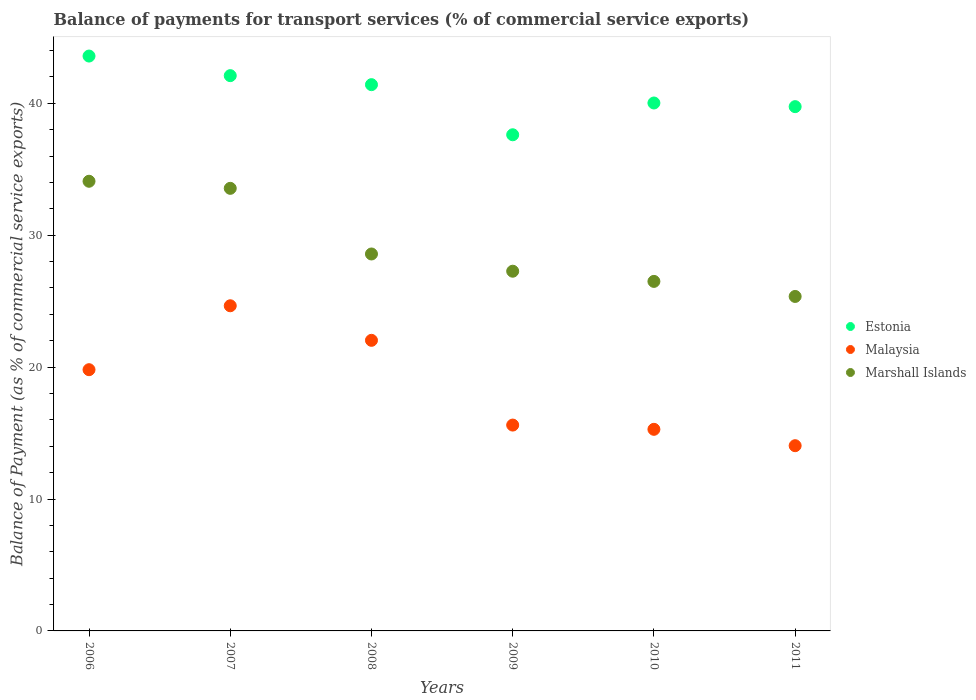How many different coloured dotlines are there?
Your response must be concise. 3. Is the number of dotlines equal to the number of legend labels?
Your answer should be very brief. Yes. What is the balance of payments for transport services in Marshall Islands in 2008?
Your response must be concise. 28.57. Across all years, what is the maximum balance of payments for transport services in Estonia?
Your response must be concise. 43.58. Across all years, what is the minimum balance of payments for transport services in Malaysia?
Your response must be concise. 14.04. In which year was the balance of payments for transport services in Malaysia maximum?
Keep it short and to the point. 2007. In which year was the balance of payments for transport services in Estonia minimum?
Keep it short and to the point. 2009. What is the total balance of payments for transport services in Marshall Islands in the graph?
Offer a very short reply. 175.33. What is the difference between the balance of payments for transport services in Malaysia in 2008 and that in 2010?
Provide a short and direct response. 6.75. What is the difference between the balance of payments for transport services in Malaysia in 2011 and the balance of payments for transport services in Estonia in 2007?
Give a very brief answer. -28.05. What is the average balance of payments for transport services in Marshall Islands per year?
Make the answer very short. 29.22. In the year 2011, what is the difference between the balance of payments for transport services in Marshall Islands and balance of payments for transport services in Malaysia?
Provide a short and direct response. 11.31. What is the ratio of the balance of payments for transport services in Marshall Islands in 2009 to that in 2010?
Provide a short and direct response. 1.03. What is the difference between the highest and the second highest balance of payments for transport services in Estonia?
Provide a short and direct response. 1.49. What is the difference between the highest and the lowest balance of payments for transport services in Malaysia?
Provide a succinct answer. 10.61. In how many years, is the balance of payments for transport services in Malaysia greater than the average balance of payments for transport services in Malaysia taken over all years?
Provide a succinct answer. 3. Does the balance of payments for transport services in Estonia monotonically increase over the years?
Your response must be concise. No. Is the balance of payments for transport services in Estonia strictly greater than the balance of payments for transport services in Marshall Islands over the years?
Your answer should be very brief. Yes. Is the balance of payments for transport services in Malaysia strictly less than the balance of payments for transport services in Marshall Islands over the years?
Make the answer very short. Yes. How many dotlines are there?
Keep it short and to the point. 3. Are the values on the major ticks of Y-axis written in scientific E-notation?
Make the answer very short. No. Does the graph contain grids?
Your answer should be very brief. No. Where does the legend appear in the graph?
Give a very brief answer. Center right. What is the title of the graph?
Your response must be concise. Balance of payments for transport services (% of commercial service exports). What is the label or title of the X-axis?
Ensure brevity in your answer.  Years. What is the label or title of the Y-axis?
Provide a succinct answer. Balance of Payment (as % of commercial service exports). What is the Balance of Payment (as % of commercial service exports) in Estonia in 2006?
Your response must be concise. 43.58. What is the Balance of Payment (as % of commercial service exports) in Malaysia in 2006?
Ensure brevity in your answer.  19.8. What is the Balance of Payment (as % of commercial service exports) of Marshall Islands in 2006?
Your answer should be compact. 34.09. What is the Balance of Payment (as % of commercial service exports) in Estonia in 2007?
Ensure brevity in your answer.  42.09. What is the Balance of Payment (as % of commercial service exports) in Malaysia in 2007?
Your response must be concise. 24.65. What is the Balance of Payment (as % of commercial service exports) in Marshall Islands in 2007?
Keep it short and to the point. 33.55. What is the Balance of Payment (as % of commercial service exports) in Estonia in 2008?
Your answer should be compact. 41.41. What is the Balance of Payment (as % of commercial service exports) in Malaysia in 2008?
Your response must be concise. 22.03. What is the Balance of Payment (as % of commercial service exports) in Marshall Islands in 2008?
Offer a very short reply. 28.57. What is the Balance of Payment (as % of commercial service exports) in Estonia in 2009?
Your answer should be very brief. 37.61. What is the Balance of Payment (as % of commercial service exports) of Malaysia in 2009?
Your answer should be compact. 15.6. What is the Balance of Payment (as % of commercial service exports) of Marshall Islands in 2009?
Provide a succinct answer. 27.27. What is the Balance of Payment (as % of commercial service exports) in Estonia in 2010?
Offer a terse response. 40.02. What is the Balance of Payment (as % of commercial service exports) in Malaysia in 2010?
Offer a very short reply. 15.28. What is the Balance of Payment (as % of commercial service exports) of Marshall Islands in 2010?
Provide a succinct answer. 26.5. What is the Balance of Payment (as % of commercial service exports) of Estonia in 2011?
Ensure brevity in your answer.  39.74. What is the Balance of Payment (as % of commercial service exports) of Malaysia in 2011?
Offer a terse response. 14.04. What is the Balance of Payment (as % of commercial service exports) of Marshall Islands in 2011?
Keep it short and to the point. 25.35. Across all years, what is the maximum Balance of Payment (as % of commercial service exports) of Estonia?
Offer a terse response. 43.58. Across all years, what is the maximum Balance of Payment (as % of commercial service exports) of Malaysia?
Your answer should be very brief. 24.65. Across all years, what is the maximum Balance of Payment (as % of commercial service exports) of Marshall Islands?
Provide a succinct answer. 34.09. Across all years, what is the minimum Balance of Payment (as % of commercial service exports) of Estonia?
Your response must be concise. 37.61. Across all years, what is the minimum Balance of Payment (as % of commercial service exports) in Malaysia?
Give a very brief answer. 14.04. Across all years, what is the minimum Balance of Payment (as % of commercial service exports) in Marshall Islands?
Your response must be concise. 25.35. What is the total Balance of Payment (as % of commercial service exports) of Estonia in the graph?
Your answer should be compact. 244.45. What is the total Balance of Payment (as % of commercial service exports) in Malaysia in the graph?
Keep it short and to the point. 111.41. What is the total Balance of Payment (as % of commercial service exports) in Marshall Islands in the graph?
Your response must be concise. 175.33. What is the difference between the Balance of Payment (as % of commercial service exports) of Estonia in 2006 and that in 2007?
Ensure brevity in your answer.  1.49. What is the difference between the Balance of Payment (as % of commercial service exports) of Malaysia in 2006 and that in 2007?
Offer a terse response. -4.85. What is the difference between the Balance of Payment (as % of commercial service exports) of Marshall Islands in 2006 and that in 2007?
Give a very brief answer. 0.54. What is the difference between the Balance of Payment (as % of commercial service exports) in Estonia in 2006 and that in 2008?
Ensure brevity in your answer.  2.17. What is the difference between the Balance of Payment (as % of commercial service exports) in Malaysia in 2006 and that in 2008?
Provide a succinct answer. -2.23. What is the difference between the Balance of Payment (as % of commercial service exports) in Marshall Islands in 2006 and that in 2008?
Ensure brevity in your answer.  5.51. What is the difference between the Balance of Payment (as % of commercial service exports) of Estonia in 2006 and that in 2009?
Provide a short and direct response. 5.97. What is the difference between the Balance of Payment (as % of commercial service exports) of Malaysia in 2006 and that in 2009?
Provide a short and direct response. 4.2. What is the difference between the Balance of Payment (as % of commercial service exports) of Marshall Islands in 2006 and that in 2009?
Offer a terse response. 6.82. What is the difference between the Balance of Payment (as % of commercial service exports) in Estonia in 2006 and that in 2010?
Give a very brief answer. 3.56. What is the difference between the Balance of Payment (as % of commercial service exports) of Malaysia in 2006 and that in 2010?
Make the answer very short. 4.52. What is the difference between the Balance of Payment (as % of commercial service exports) in Marshall Islands in 2006 and that in 2010?
Offer a terse response. 7.59. What is the difference between the Balance of Payment (as % of commercial service exports) of Estonia in 2006 and that in 2011?
Your answer should be compact. 3.83. What is the difference between the Balance of Payment (as % of commercial service exports) in Malaysia in 2006 and that in 2011?
Offer a very short reply. 5.76. What is the difference between the Balance of Payment (as % of commercial service exports) of Marshall Islands in 2006 and that in 2011?
Offer a very short reply. 8.73. What is the difference between the Balance of Payment (as % of commercial service exports) in Estonia in 2007 and that in 2008?
Give a very brief answer. 0.68. What is the difference between the Balance of Payment (as % of commercial service exports) of Malaysia in 2007 and that in 2008?
Provide a succinct answer. 2.62. What is the difference between the Balance of Payment (as % of commercial service exports) of Marshall Islands in 2007 and that in 2008?
Give a very brief answer. 4.98. What is the difference between the Balance of Payment (as % of commercial service exports) in Estonia in 2007 and that in 2009?
Offer a very short reply. 4.48. What is the difference between the Balance of Payment (as % of commercial service exports) in Malaysia in 2007 and that in 2009?
Ensure brevity in your answer.  9.04. What is the difference between the Balance of Payment (as % of commercial service exports) in Marshall Islands in 2007 and that in 2009?
Your response must be concise. 6.28. What is the difference between the Balance of Payment (as % of commercial service exports) of Estonia in 2007 and that in 2010?
Your answer should be compact. 2.07. What is the difference between the Balance of Payment (as % of commercial service exports) of Malaysia in 2007 and that in 2010?
Keep it short and to the point. 9.37. What is the difference between the Balance of Payment (as % of commercial service exports) of Marshall Islands in 2007 and that in 2010?
Offer a very short reply. 7.05. What is the difference between the Balance of Payment (as % of commercial service exports) in Estonia in 2007 and that in 2011?
Keep it short and to the point. 2.35. What is the difference between the Balance of Payment (as % of commercial service exports) of Malaysia in 2007 and that in 2011?
Offer a terse response. 10.61. What is the difference between the Balance of Payment (as % of commercial service exports) in Marshall Islands in 2007 and that in 2011?
Ensure brevity in your answer.  8.2. What is the difference between the Balance of Payment (as % of commercial service exports) of Estonia in 2008 and that in 2009?
Give a very brief answer. 3.8. What is the difference between the Balance of Payment (as % of commercial service exports) in Malaysia in 2008 and that in 2009?
Your answer should be compact. 6.42. What is the difference between the Balance of Payment (as % of commercial service exports) in Marshall Islands in 2008 and that in 2009?
Provide a short and direct response. 1.31. What is the difference between the Balance of Payment (as % of commercial service exports) in Estonia in 2008 and that in 2010?
Give a very brief answer. 1.39. What is the difference between the Balance of Payment (as % of commercial service exports) in Malaysia in 2008 and that in 2010?
Give a very brief answer. 6.75. What is the difference between the Balance of Payment (as % of commercial service exports) of Marshall Islands in 2008 and that in 2010?
Provide a short and direct response. 2.08. What is the difference between the Balance of Payment (as % of commercial service exports) in Estonia in 2008 and that in 2011?
Your answer should be compact. 1.67. What is the difference between the Balance of Payment (as % of commercial service exports) in Malaysia in 2008 and that in 2011?
Keep it short and to the point. 7.99. What is the difference between the Balance of Payment (as % of commercial service exports) in Marshall Islands in 2008 and that in 2011?
Make the answer very short. 3.22. What is the difference between the Balance of Payment (as % of commercial service exports) of Estonia in 2009 and that in 2010?
Ensure brevity in your answer.  -2.41. What is the difference between the Balance of Payment (as % of commercial service exports) of Malaysia in 2009 and that in 2010?
Your response must be concise. 0.32. What is the difference between the Balance of Payment (as % of commercial service exports) of Marshall Islands in 2009 and that in 2010?
Offer a very short reply. 0.77. What is the difference between the Balance of Payment (as % of commercial service exports) in Estonia in 2009 and that in 2011?
Provide a succinct answer. -2.13. What is the difference between the Balance of Payment (as % of commercial service exports) in Malaysia in 2009 and that in 2011?
Your answer should be compact. 1.56. What is the difference between the Balance of Payment (as % of commercial service exports) of Marshall Islands in 2009 and that in 2011?
Keep it short and to the point. 1.91. What is the difference between the Balance of Payment (as % of commercial service exports) of Estonia in 2010 and that in 2011?
Your answer should be very brief. 0.28. What is the difference between the Balance of Payment (as % of commercial service exports) of Malaysia in 2010 and that in 2011?
Give a very brief answer. 1.24. What is the difference between the Balance of Payment (as % of commercial service exports) of Marshall Islands in 2010 and that in 2011?
Your answer should be compact. 1.14. What is the difference between the Balance of Payment (as % of commercial service exports) in Estonia in 2006 and the Balance of Payment (as % of commercial service exports) in Malaysia in 2007?
Your response must be concise. 18.93. What is the difference between the Balance of Payment (as % of commercial service exports) of Estonia in 2006 and the Balance of Payment (as % of commercial service exports) of Marshall Islands in 2007?
Make the answer very short. 10.03. What is the difference between the Balance of Payment (as % of commercial service exports) of Malaysia in 2006 and the Balance of Payment (as % of commercial service exports) of Marshall Islands in 2007?
Your response must be concise. -13.75. What is the difference between the Balance of Payment (as % of commercial service exports) of Estonia in 2006 and the Balance of Payment (as % of commercial service exports) of Malaysia in 2008?
Give a very brief answer. 21.55. What is the difference between the Balance of Payment (as % of commercial service exports) of Estonia in 2006 and the Balance of Payment (as % of commercial service exports) of Marshall Islands in 2008?
Give a very brief answer. 15. What is the difference between the Balance of Payment (as % of commercial service exports) in Malaysia in 2006 and the Balance of Payment (as % of commercial service exports) in Marshall Islands in 2008?
Offer a terse response. -8.77. What is the difference between the Balance of Payment (as % of commercial service exports) in Estonia in 2006 and the Balance of Payment (as % of commercial service exports) in Malaysia in 2009?
Keep it short and to the point. 27.97. What is the difference between the Balance of Payment (as % of commercial service exports) in Estonia in 2006 and the Balance of Payment (as % of commercial service exports) in Marshall Islands in 2009?
Offer a very short reply. 16.31. What is the difference between the Balance of Payment (as % of commercial service exports) in Malaysia in 2006 and the Balance of Payment (as % of commercial service exports) in Marshall Islands in 2009?
Offer a very short reply. -7.46. What is the difference between the Balance of Payment (as % of commercial service exports) of Estonia in 2006 and the Balance of Payment (as % of commercial service exports) of Malaysia in 2010?
Offer a terse response. 28.3. What is the difference between the Balance of Payment (as % of commercial service exports) of Estonia in 2006 and the Balance of Payment (as % of commercial service exports) of Marshall Islands in 2010?
Make the answer very short. 17.08. What is the difference between the Balance of Payment (as % of commercial service exports) in Malaysia in 2006 and the Balance of Payment (as % of commercial service exports) in Marshall Islands in 2010?
Your answer should be very brief. -6.69. What is the difference between the Balance of Payment (as % of commercial service exports) of Estonia in 2006 and the Balance of Payment (as % of commercial service exports) of Malaysia in 2011?
Make the answer very short. 29.54. What is the difference between the Balance of Payment (as % of commercial service exports) in Estonia in 2006 and the Balance of Payment (as % of commercial service exports) in Marshall Islands in 2011?
Your answer should be very brief. 18.22. What is the difference between the Balance of Payment (as % of commercial service exports) in Malaysia in 2006 and the Balance of Payment (as % of commercial service exports) in Marshall Islands in 2011?
Your answer should be compact. -5.55. What is the difference between the Balance of Payment (as % of commercial service exports) in Estonia in 2007 and the Balance of Payment (as % of commercial service exports) in Malaysia in 2008?
Provide a succinct answer. 20.06. What is the difference between the Balance of Payment (as % of commercial service exports) in Estonia in 2007 and the Balance of Payment (as % of commercial service exports) in Marshall Islands in 2008?
Provide a short and direct response. 13.52. What is the difference between the Balance of Payment (as % of commercial service exports) of Malaysia in 2007 and the Balance of Payment (as % of commercial service exports) of Marshall Islands in 2008?
Your response must be concise. -3.93. What is the difference between the Balance of Payment (as % of commercial service exports) in Estonia in 2007 and the Balance of Payment (as % of commercial service exports) in Malaysia in 2009?
Give a very brief answer. 26.49. What is the difference between the Balance of Payment (as % of commercial service exports) in Estonia in 2007 and the Balance of Payment (as % of commercial service exports) in Marshall Islands in 2009?
Make the answer very short. 14.82. What is the difference between the Balance of Payment (as % of commercial service exports) of Malaysia in 2007 and the Balance of Payment (as % of commercial service exports) of Marshall Islands in 2009?
Your response must be concise. -2.62. What is the difference between the Balance of Payment (as % of commercial service exports) in Estonia in 2007 and the Balance of Payment (as % of commercial service exports) in Malaysia in 2010?
Ensure brevity in your answer.  26.81. What is the difference between the Balance of Payment (as % of commercial service exports) of Estonia in 2007 and the Balance of Payment (as % of commercial service exports) of Marshall Islands in 2010?
Your answer should be very brief. 15.6. What is the difference between the Balance of Payment (as % of commercial service exports) of Malaysia in 2007 and the Balance of Payment (as % of commercial service exports) of Marshall Islands in 2010?
Your answer should be compact. -1.85. What is the difference between the Balance of Payment (as % of commercial service exports) in Estonia in 2007 and the Balance of Payment (as % of commercial service exports) in Malaysia in 2011?
Your answer should be compact. 28.05. What is the difference between the Balance of Payment (as % of commercial service exports) of Estonia in 2007 and the Balance of Payment (as % of commercial service exports) of Marshall Islands in 2011?
Keep it short and to the point. 16.74. What is the difference between the Balance of Payment (as % of commercial service exports) of Malaysia in 2007 and the Balance of Payment (as % of commercial service exports) of Marshall Islands in 2011?
Offer a very short reply. -0.71. What is the difference between the Balance of Payment (as % of commercial service exports) in Estonia in 2008 and the Balance of Payment (as % of commercial service exports) in Malaysia in 2009?
Keep it short and to the point. 25.8. What is the difference between the Balance of Payment (as % of commercial service exports) of Estonia in 2008 and the Balance of Payment (as % of commercial service exports) of Marshall Islands in 2009?
Provide a succinct answer. 14.14. What is the difference between the Balance of Payment (as % of commercial service exports) of Malaysia in 2008 and the Balance of Payment (as % of commercial service exports) of Marshall Islands in 2009?
Your answer should be compact. -5.24. What is the difference between the Balance of Payment (as % of commercial service exports) in Estonia in 2008 and the Balance of Payment (as % of commercial service exports) in Malaysia in 2010?
Provide a succinct answer. 26.13. What is the difference between the Balance of Payment (as % of commercial service exports) in Estonia in 2008 and the Balance of Payment (as % of commercial service exports) in Marshall Islands in 2010?
Offer a very short reply. 14.91. What is the difference between the Balance of Payment (as % of commercial service exports) in Malaysia in 2008 and the Balance of Payment (as % of commercial service exports) in Marshall Islands in 2010?
Your response must be concise. -4.47. What is the difference between the Balance of Payment (as % of commercial service exports) in Estonia in 2008 and the Balance of Payment (as % of commercial service exports) in Malaysia in 2011?
Make the answer very short. 27.37. What is the difference between the Balance of Payment (as % of commercial service exports) of Estonia in 2008 and the Balance of Payment (as % of commercial service exports) of Marshall Islands in 2011?
Your answer should be very brief. 16.05. What is the difference between the Balance of Payment (as % of commercial service exports) of Malaysia in 2008 and the Balance of Payment (as % of commercial service exports) of Marshall Islands in 2011?
Your answer should be compact. -3.33. What is the difference between the Balance of Payment (as % of commercial service exports) in Estonia in 2009 and the Balance of Payment (as % of commercial service exports) in Malaysia in 2010?
Give a very brief answer. 22.33. What is the difference between the Balance of Payment (as % of commercial service exports) of Estonia in 2009 and the Balance of Payment (as % of commercial service exports) of Marshall Islands in 2010?
Your response must be concise. 11.11. What is the difference between the Balance of Payment (as % of commercial service exports) of Malaysia in 2009 and the Balance of Payment (as % of commercial service exports) of Marshall Islands in 2010?
Provide a short and direct response. -10.89. What is the difference between the Balance of Payment (as % of commercial service exports) in Estonia in 2009 and the Balance of Payment (as % of commercial service exports) in Malaysia in 2011?
Keep it short and to the point. 23.57. What is the difference between the Balance of Payment (as % of commercial service exports) in Estonia in 2009 and the Balance of Payment (as % of commercial service exports) in Marshall Islands in 2011?
Your answer should be very brief. 12.26. What is the difference between the Balance of Payment (as % of commercial service exports) in Malaysia in 2009 and the Balance of Payment (as % of commercial service exports) in Marshall Islands in 2011?
Your answer should be very brief. -9.75. What is the difference between the Balance of Payment (as % of commercial service exports) in Estonia in 2010 and the Balance of Payment (as % of commercial service exports) in Malaysia in 2011?
Ensure brevity in your answer.  25.98. What is the difference between the Balance of Payment (as % of commercial service exports) in Estonia in 2010 and the Balance of Payment (as % of commercial service exports) in Marshall Islands in 2011?
Provide a succinct answer. 14.66. What is the difference between the Balance of Payment (as % of commercial service exports) of Malaysia in 2010 and the Balance of Payment (as % of commercial service exports) of Marshall Islands in 2011?
Make the answer very short. -10.07. What is the average Balance of Payment (as % of commercial service exports) in Estonia per year?
Your answer should be very brief. 40.74. What is the average Balance of Payment (as % of commercial service exports) of Malaysia per year?
Offer a very short reply. 18.57. What is the average Balance of Payment (as % of commercial service exports) in Marshall Islands per year?
Offer a terse response. 29.22. In the year 2006, what is the difference between the Balance of Payment (as % of commercial service exports) of Estonia and Balance of Payment (as % of commercial service exports) of Malaysia?
Give a very brief answer. 23.77. In the year 2006, what is the difference between the Balance of Payment (as % of commercial service exports) in Estonia and Balance of Payment (as % of commercial service exports) in Marshall Islands?
Your response must be concise. 9.49. In the year 2006, what is the difference between the Balance of Payment (as % of commercial service exports) in Malaysia and Balance of Payment (as % of commercial service exports) in Marshall Islands?
Give a very brief answer. -14.28. In the year 2007, what is the difference between the Balance of Payment (as % of commercial service exports) in Estonia and Balance of Payment (as % of commercial service exports) in Malaysia?
Make the answer very short. 17.44. In the year 2007, what is the difference between the Balance of Payment (as % of commercial service exports) of Estonia and Balance of Payment (as % of commercial service exports) of Marshall Islands?
Your answer should be very brief. 8.54. In the year 2007, what is the difference between the Balance of Payment (as % of commercial service exports) in Malaysia and Balance of Payment (as % of commercial service exports) in Marshall Islands?
Give a very brief answer. -8.9. In the year 2008, what is the difference between the Balance of Payment (as % of commercial service exports) of Estonia and Balance of Payment (as % of commercial service exports) of Malaysia?
Keep it short and to the point. 19.38. In the year 2008, what is the difference between the Balance of Payment (as % of commercial service exports) in Estonia and Balance of Payment (as % of commercial service exports) in Marshall Islands?
Keep it short and to the point. 12.84. In the year 2008, what is the difference between the Balance of Payment (as % of commercial service exports) in Malaysia and Balance of Payment (as % of commercial service exports) in Marshall Islands?
Provide a short and direct response. -6.55. In the year 2009, what is the difference between the Balance of Payment (as % of commercial service exports) in Estonia and Balance of Payment (as % of commercial service exports) in Malaysia?
Your response must be concise. 22.01. In the year 2009, what is the difference between the Balance of Payment (as % of commercial service exports) in Estonia and Balance of Payment (as % of commercial service exports) in Marshall Islands?
Provide a succinct answer. 10.34. In the year 2009, what is the difference between the Balance of Payment (as % of commercial service exports) of Malaysia and Balance of Payment (as % of commercial service exports) of Marshall Islands?
Offer a terse response. -11.66. In the year 2010, what is the difference between the Balance of Payment (as % of commercial service exports) of Estonia and Balance of Payment (as % of commercial service exports) of Malaysia?
Offer a terse response. 24.74. In the year 2010, what is the difference between the Balance of Payment (as % of commercial service exports) of Estonia and Balance of Payment (as % of commercial service exports) of Marshall Islands?
Give a very brief answer. 13.52. In the year 2010, what is the difference between the Balance of Payment (as % of commercial service exports) in Malaysia and Balance of Payment (as % of commercial service exports) in Marshall Islands?
Make the answer very short. -11.21. In the year 2011, what is the difference between the Balance of Payment (as % of commercial service exports) in Estonia and Balance of Payment (as % of commercial service exports) in Malaysia?
Give a very brief answer. 25.7. In the year 2011, what is the difference between the Balance of Payment (as % of commercial service exports) in Estonia and Balance of Payment (as % of commercial service exports) in Marshall Islands?
Offer a very short reply. 14.39. In the year 2011, what is the difference between the Balance of Payment (as % of commercial service exports) of Malaysia and Balance of Payment (as % of commercial service exports) of Marshall Islands?
Offer a terse response. -11.31. What is the ratio of the Balance of Payment (as % of commercial service exports) of Estonia in 2006 to that in 2007?
Make the answer very short. 1.04. What is the ratio of the Balance of Payment (as % of commercial service exports) in Malaysia in 2006 to that in 2007?
Your answer should be very brief. 0.8. What is the ratio of the Balance of Payment (as % of commercial service exports) in Estonia in 2006 to that in 2008?
Provide a short and direct response. 1.05. What is the ratio of the Balance of Payment (as % of commercial service exports) of Malaysia in 2006 to that in 2008?
Provide a short and direct response. 0.9. What is the ratio of the Balance of Payment (as % of commercial service exports) in Marshall Islands in 2006 to that in 2008?
Provide a short and direct response. 1.19. What is the ratio of the Balance of Payment (as % of commercial service exports) in Estonia in 2006 to that in 2009?
Your answer should be very brief. 1.16. What is the ratio of the Balance of Payment (as % of commercial service exports) in Malaysia in 2006 to that in 2009?
Provide a short and direct response. 1.27. What is the ratio of the Balance of Payment (as % of commercial service exports) in Marshall Islands in 2006 to that in 2009?
Give a very brief answer. 1.25. What is the ratio of the Balance of Payment (as % of commercial service exports) in Estonia in 2006 to that in 2010?
Ensure brevity in your answer.  1.09. What is the ratio of the Balance of Payment (as % of commercial service exports) in Malaysia in 2006 to that in 2010?
Your response must be concise. 1.3. What is the ratio of the Balance of Payment (as % of commercial service exports) of Marshall Islands in 2006 to that in 2010?
Keep it short and to the point. 1.29. What is the ratio of the Balance of Payment (as % of commercial service exports) of Estonia in 2006 to that in 2011?
Your response must be concise. 1.1. What is the ratio of the Balance of Payment (as % of commercial service exports) of Malaysia in 2006 to that in 2011?
Your answer should be very brief. 1.41. What is the ratio of the Balance of Payment (as % of commercial service exports) of Marshall Islands in 2006 to that in 2011?
Make the answer very short. 1.34. What is the ratio of the Balance of Payment (as % of commercial service exports) in Estonia in 2007 to that in 2008?
Your answer should be very brief. 1.02. What is the ratio of the Balance of Payment (as % of commercial service exports) in Malaysia in 2007 to that in 2008?
Your answer should be compact. 1.12. What is the ratio of the Balance of Payment (as % of commercial service exports) of Marshall Islands in 2007 to that in 2008?
Your answer should be very brief. 1.17. What is the ratio of the Balance of Payment (as % of commercial service exports) of Estonia in 2007 to that in 2009?
Your answer should be very brief. 1.12. What is the ratio of the Balance of Payment (as % of commercial service exports) in Malaysia in 2007 to that in 2009?
Keep it short and to the point. 1.58. What is the ratio of the Balance of Payment (as % of commercial service exports) in Marshall Islands in 2007 to that in 2009?
Give a very brief answer. 1.23. What is the ratio of the Balance of Payment (as % of commercial service exports) of Estonia in 2007 to that in 2010?
Provide a short and direct response. 1.05. What is the ratio of the Balance of Payment (as % of commercial service exports) of Malaysia in 2007 to that in 2010?
Make the answer very short. 1.61. What is the ratio of the Balance of Payment (as % of commercial service exports) in Marshall Islands in 2007 to that in 2010?
Offer a terse response. 1.27. What is the ratio of the Balance of Payment (as % of commercial service exports) of Estonia in 2007 to that in 2011?
Ensure brevity in your answer.  1.06. What is the ratio of the Balance of Payment (as % of commercial service exports) in Malaysia in 2007 to that in 2011?
Provide a succinct answer. 1.76. What is the ratio of the Balance of Payment (as % of commercial service exports) of Marshall Islands in 2007 to that in 2011?
Offer a terse response. 1.32. What is the ratio of the Balance of Payment (as % of commercial service exports) in Estonia in 2008 to that in 2009?
Your answer should be very brief. 1.1. What is the ratio of the Balance of Payment (as % of commercial service exports) of Malaysia in 2008 to that in 2009?
Offer a very short reply. 1.41. What is the ratio of the Balance of Payment (as % of commercial service exports) of Marshall Islands in 2008 to that in 2009?
Ensure brevity in your answer.  1.05. What is the ratio of the Balance of Payment (as % of commercial service exports) in Estonia in 2008 to that in 2010?
Offer a very short reply. 1.03. What is the ratio of the Balance of Payment (as % of commercial service exports) of Malaysia in 2008 to that in 2010?
Make the answer very short. 1.44. What is the ratio of the Balance of Payment (as % of commercial service exports) in Marshall Islands in 2008 to that in 2010?
Offer a very short reply. 1.08. What is the ratio of the Balance of Payment (as % of commercial service exports) of Estonia in 2008 to that in 2011?
Give a very brief answer. 1.04. What is the ratio of the Balance of Payment (as % of commercial service exports) in Malaysia in 2008 to that in 2011?
Your response must be concise. 1.57. What is the ratio of the Balance of Payment (as % of commercial service exports) in Marshall Islands in 2008 to that in 2011?
Provide a succinct answer. 1.13. What is the ratio of the Balance of Payment (as % of commercial service exports) in Estonia in 2009 to that in 2010?
Offer a very short reply. 0.94. What is the ratio of the Balance of Payment (as % of commercial service exports) of Malaysia in 2009 to that in 2010?
Make the answer very short. 1.02. What is the ratio of the Balance of Payment (as % of commercial service exports) of Marshall Islands in 2009 to that in 2010?
Keep it short and to the point. 1.03. What is the ratio of the Balance of Payment (as % of commercial service exports) in Estonia in 2009 to that in 2011?
Your answer should be compact. 0.95. What is the ratio of the Balance of Payment (as % of commercial service exports) in Malaysia in 2009 to that in 2011?
Offer a very short reply. 1.11. What is the ratio of the Balance of Payment (as % of commercial service exports) of Marshall Islands in 2009 to that in 2011?
Offer a terse response. 1.08. What is the ratio of the Balance of Payment (as % of commercial service exports) in Malaysia in 2010 to that in 2011?
Your answer should be compact. 1.09. What is the ratio of the Balance of Payment (as % of commercial service exports) of Marshall Islands in 2010 to that in 2011?
Give a very brief answer. 1.04. What is the difference between the highest and the second highest Balance of Payment (as % of commercial service exports) in Estonia?
Keep it short and to the point. 1.49. What is the difference between the highest and the second highest Balance of Payment (as % of commercial service exports) of Malaysia?
Make the answer very short. 2.62. What is the difference between the highest and the second highest Balance of Payment (as % of commercial service exports) in Marshall Islands?
Give a very brief answer. 0.54. What is the difference between the highest and the lowest Balance of Payment (as % of commercial service exports) in Estonia?
Keep it short and to the point. 5.97. What is the difference between the highest and the lowest Balance of Payment (as % of commercial service exports) in Malaysia?
Offer a terse response. 10.61. What is the difference between the highest and the lowest Balance of Payment (as % of commercial service exports) in Marshall Islands?
Provide a succinct answer. 8.73. 